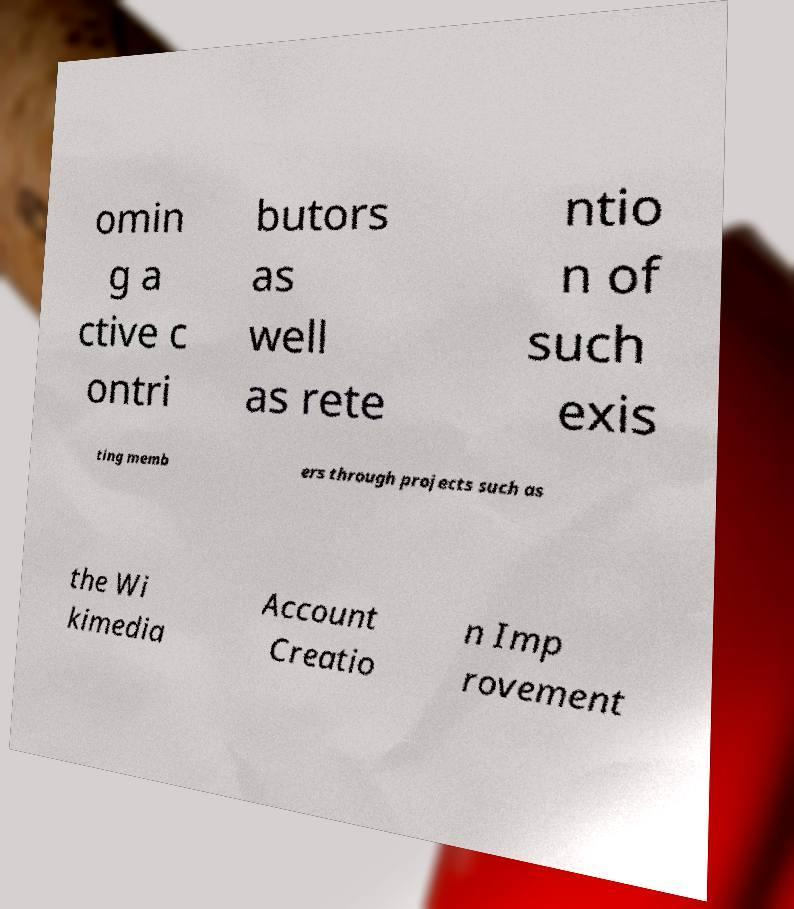Can you read and provide the text displayed in the image?This photo seems to have some interesting text. Can you extract and type it out for me? omin g a ctive c ontri butors as well as rete ntio n of such exis ting memb ers through projects such as the Wi kimedia Account Creatio n Imp rovement 